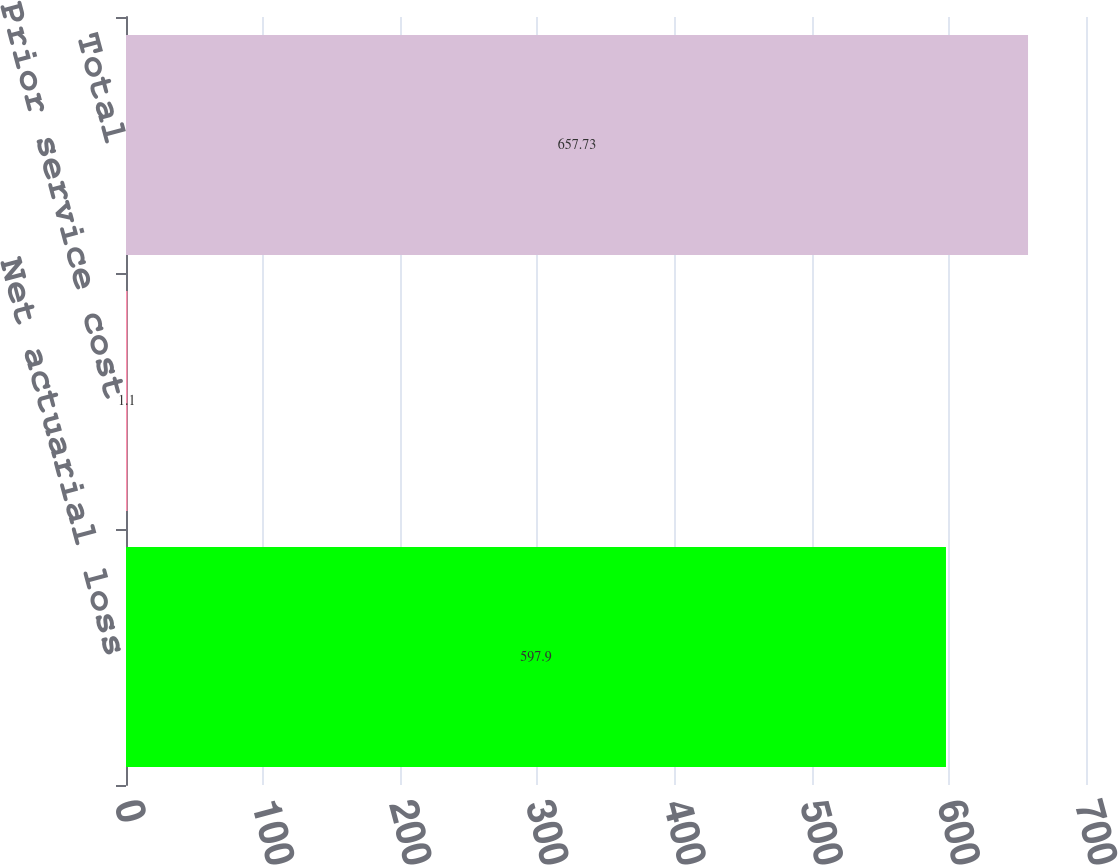Convert chart to OTSL. <chart><loc_0><loc_0><loc_500><loc_500><bar_chart><fcel>Net actuarial loss<fcel>Prior service cost<fcel>Total<nl><fcel>597.9<fcel>1.1<fcel>657.73<nl></chart> 